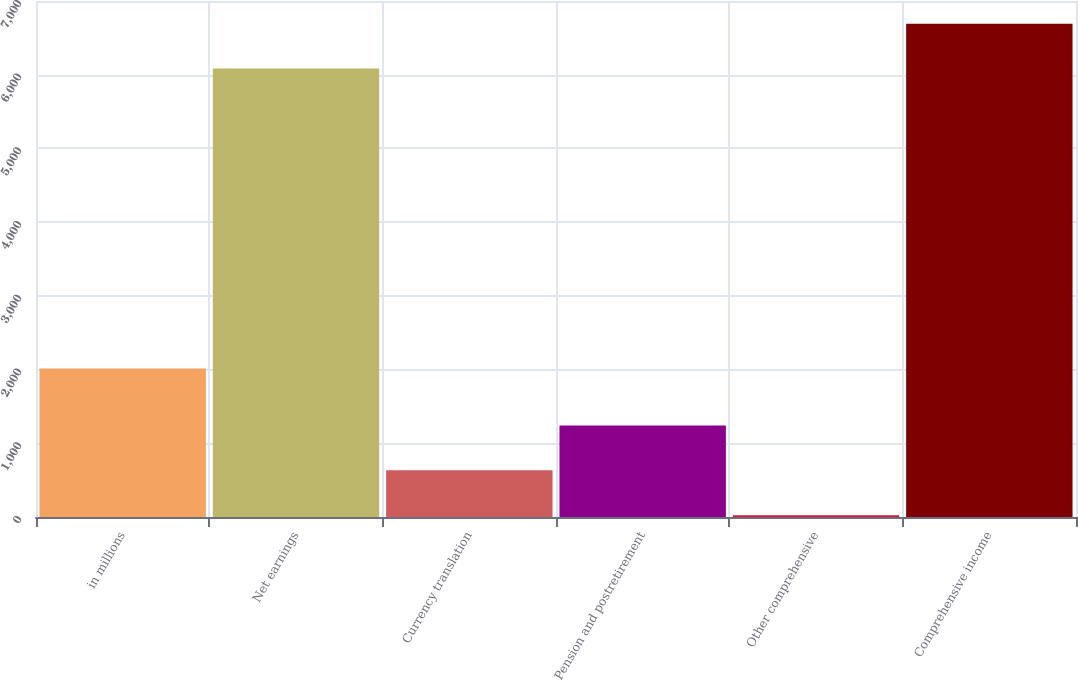Convert chart to OTSL. <chart><loc_0><loc_0><loc_500><loc_500><bar_chart><fcel>in millions<fcel>Net earnings<fcel>Currency translation<fcel>Pension and postretirement<fcel>Other comprehensive<fcel>Comprehensive income<nl><fcel>2015<fcel>6083<fcel>633.3<fcel>1241.6<fcel>25<fcel>6691.3<nl></chart> 